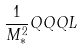Convert formula to latex. <formula><loc_0><loc_0><loc_500><loc_500>\frac { 1 } { M _ { * } ^ { 2 } } Q Q Q L</formula> 